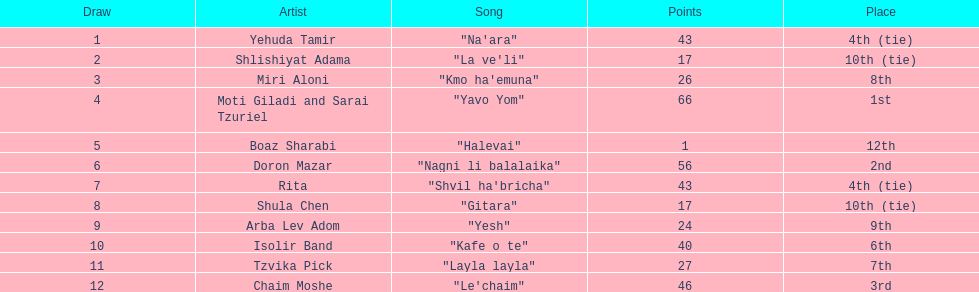What song earned the most points? "Yavo Yom". 